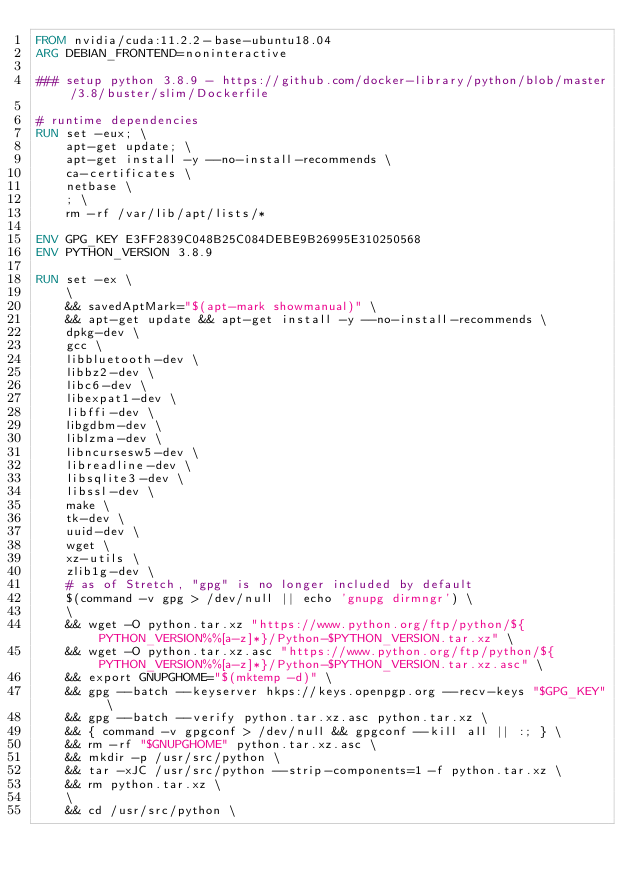<code> <loc_0><loc_0><loc_500><loc_500><_Dockerfile_>FROM nvidia/cuda:11.2.2-base-ubuntu18.04
ARG DEBIAN_FRONTEND=noninteractive

### setup python 3.8.9 - https://github.com/docker-library/python/blob/master/3.8/buster/slim/Dockerfile

# runtime dependencies
RUN set -eux; \
    apt-get update; \
    apt-get install -y --no-install-recommends \
    ca-certificates \
    netbase \
    ; \
    rm -rf /var/lib/apt/lists/*

ENV GPG_KEY E3FF2839C048B25C084DEBE9B26995E310250568
ENV PYTHON_VERSION 3.8.9

RUN set -ex \
    \
    && savedAptMark="$(apt-mark showmanual)" \
    && apt-get update && apt-get install -y --no-install-recommends \
    dpkg-dev \
    gcc \
    libbluetooth-dev \
    libbz2-dev \
    libc6-dev \
    libexpat1-dev \
    libffi-dev \
    libgdbm-dev \
    liblzma-dev \
    libncursesw5-dev \
    libreadline-dev \
    libsqlite3-dev \
    libssl-dev \
    make \
    tk-dev \
    uuid-dev \
    wget \
    xz-utils \
    zlib1g-dev \
    # as of Stretch, "gpg" is no longer included by default
    $(command -v gpg > /dev/null || echo 'gnupg dirmngr') \
    \
    && wget -O python.tar.xz "https://www.python.org/ftp/python/${PYTHON_VERSION%%[a-z]*}/Python-$PYTHON_VERSION.tar.xz" \
    && wget -O python.tar.xz.asc "https://www.python.org/ftp/python/${PYTHON_VERSION%%[a-z]*}/Python-$PYTHON_VERSION.tar.xz.asc" \
    && export GNUPGHOME="$(mktemp -d)" \
    && gpg --batch --keyserver hkps://keys.openpgp.org --recv-keys "$GPG_KEY" \
    && gpg --batch --verify python.tar.xz.asc python.tar.xz \
    && { command -v gpgconf > /dev/null && gpgconf --kill all || :; } \
    && rm -rf "$GNUPGHOME" python.tar.xz.asc \
    && mkdir -p /usr/src/python \
    && tar -xJC /usr/src/python --strip-components=1 -f python.tar.xz \
    && rm python.tar.xz \
    \
    && cd /usr/src/python \</code> 